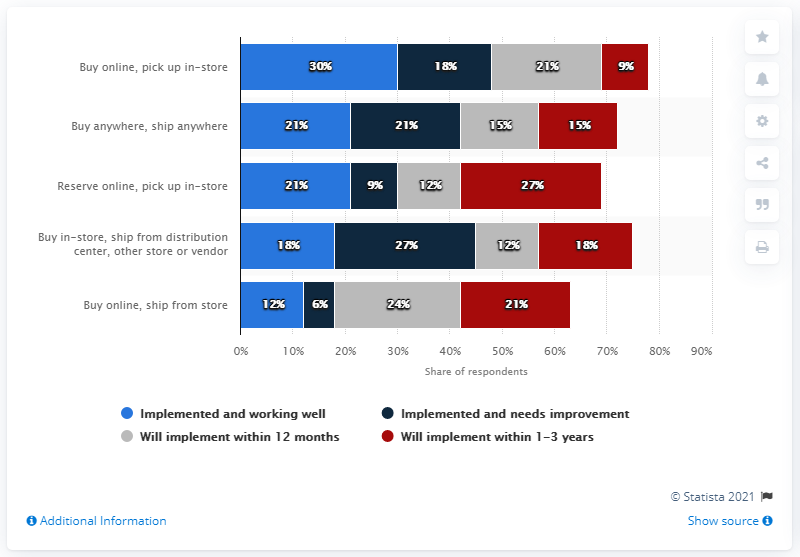Identify some key points in this picture. The difference between the maximum navy blue bar and the minimum grey bar is 15. The highest value of the dark blue bar is 27. 